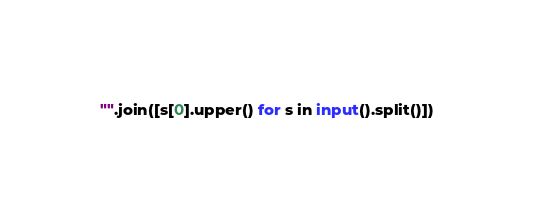<code> <loc_0><loc_0><loc_500><loc_500><_Python_>"".join([s[0].upper() for s in input().split()])</code> 